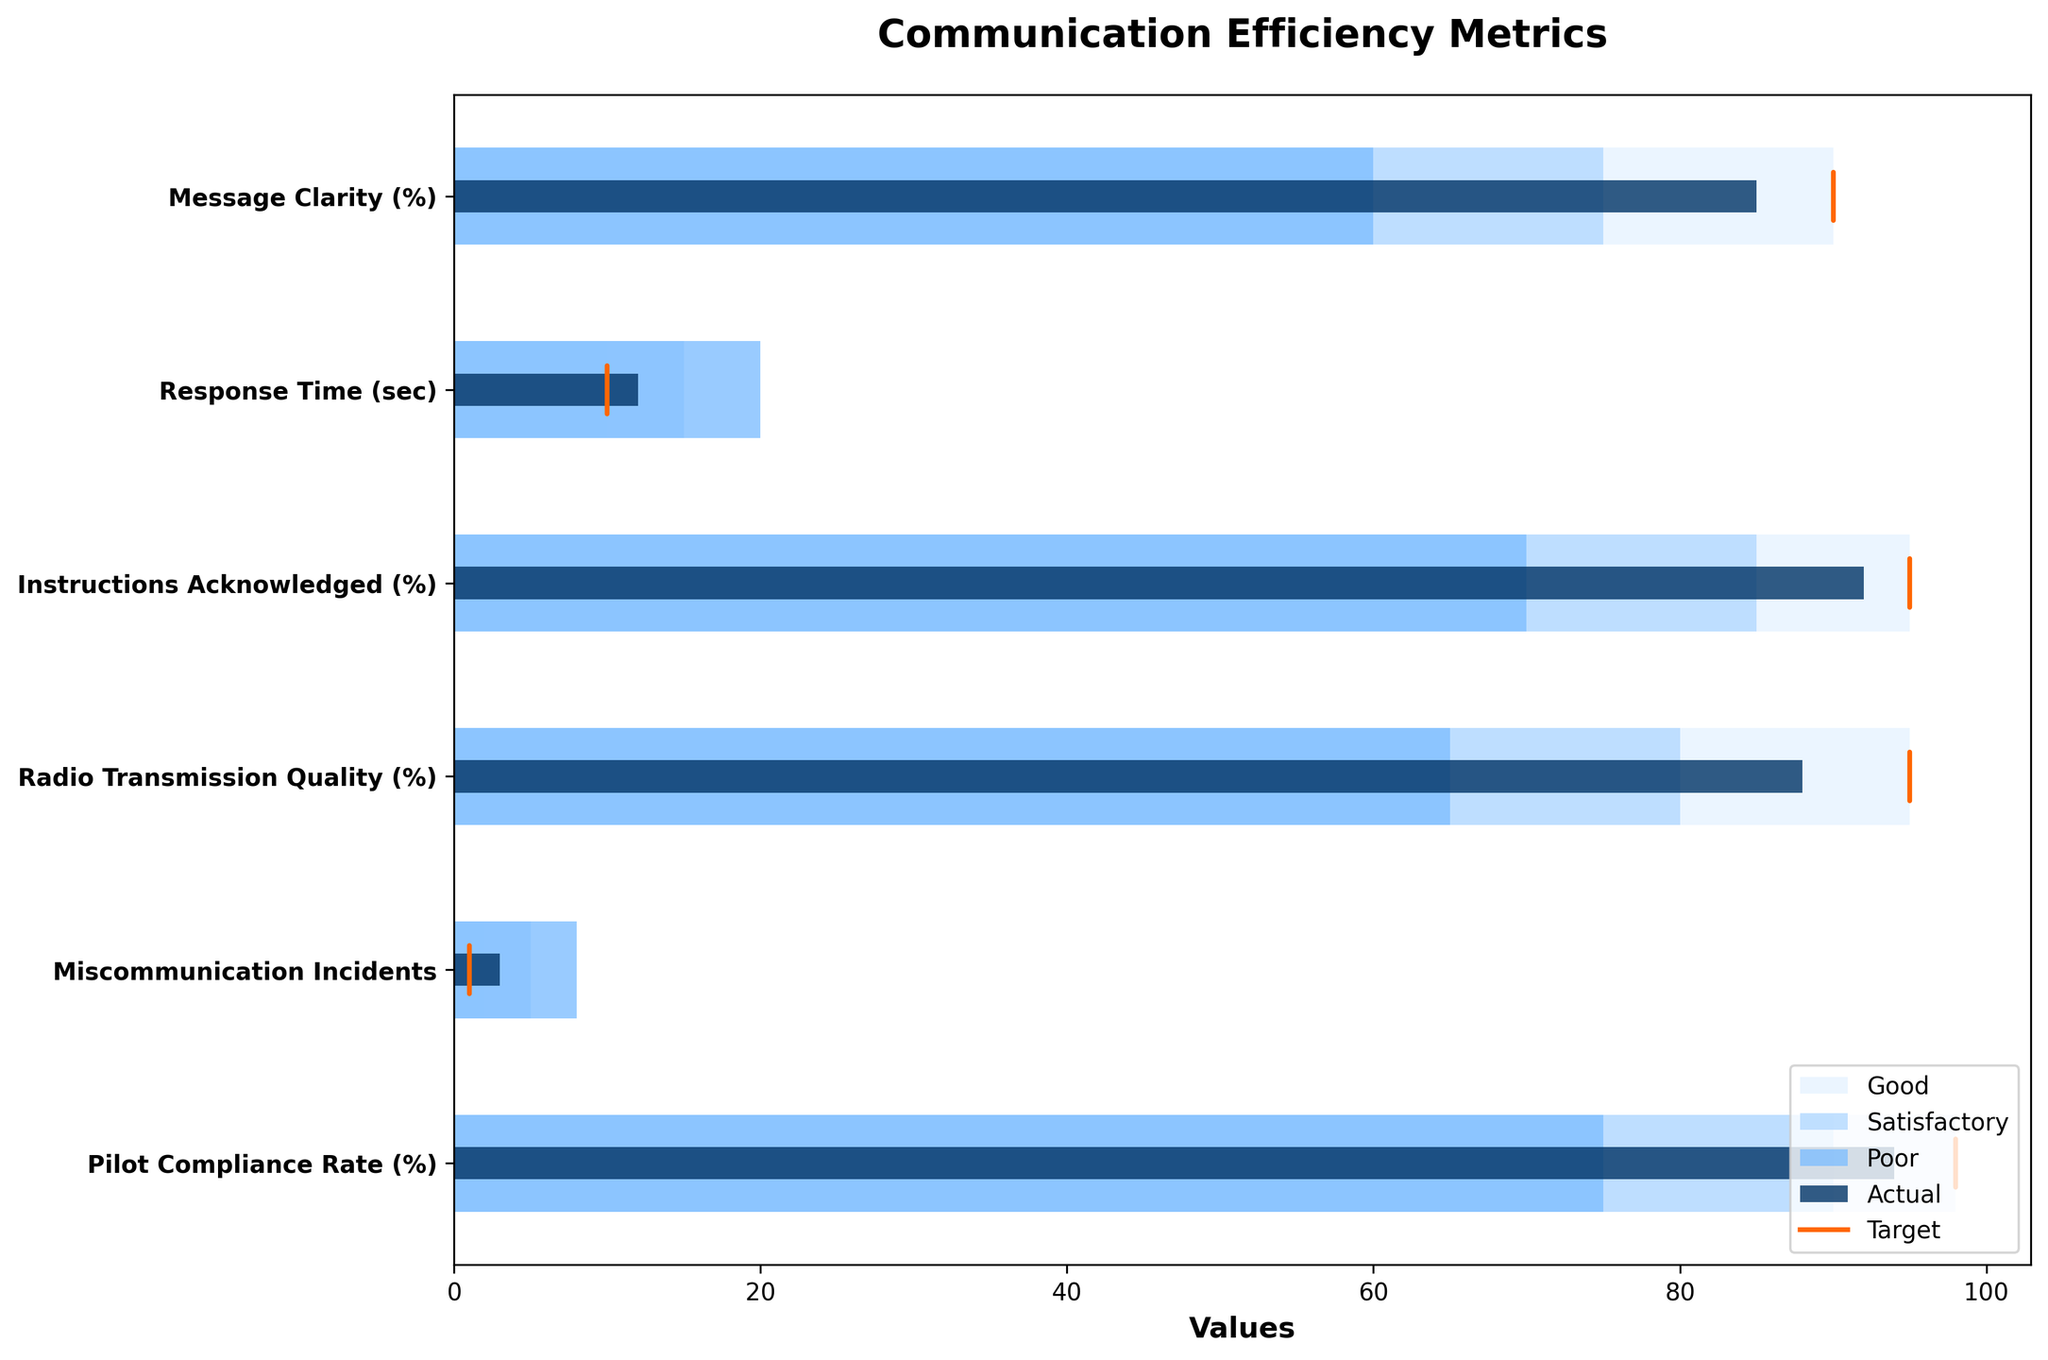What's the title of the plot? The title is usually placed at the top of the figure and summarizes the main focus of the plot.
Answer: Communication Efficiency Metrics Which metric has the lowest actual value? By observing the actual values represented by the dark bars, the metric with the smallest bar is “Miscommunication Incidents”.
Answer: Miscommunication Incidents How many metrics have an actual value that exceeds their target? Compare the end of each dark bar (actual value) with the corresponding orange line (target value). None of the actual values exceed their target values.
Answer: 0 How many metrics fall into the "Good" category based on their actual values? Any actual value bar that reaches or exceeds the boundary of the light blue area (marked as “Good”) is considered as falling into the "Good" category.
Answer: 0 Which metric is furthest from reaching its target value? Find the metric where the difference between the actual value (end of the dark bar) and the target value (orange line) is the greatest. This is “Miscommunication Incidents”.
Answer: Miscommunication Incidents What's the difference between the target and actual value for "Response Time (sec)"? Subtract the actual value for "Response Time (sec)" from its target value: 12 (actual) - 10 (target) = 2.
Answer: 2 Which metric has the closest actual value to its target? Compare the distances between the actual values (end of the dark bars) and the target values (orange lines). The closest is "Message Clarity (%)" with a difference of 5.
Answer: Message Clarity (%) Rank the metrics from worst to best in terms of how close their actual values are to their "Good" thresholds. Calculate the difference between the actual value and the "Good" threshold for each metric, ranking them from greatest to smallest. The order is: "Miscommunication Incidents", "Response Time (sec)", "Radio Transmission Quality (%)", "Pilot Compliance Rate (%)", "Instructions Acknowledged (%)", "Message Clarity (%)".
Answer: Miscommunication Incidents, Response Time, Radio Transmission Quality, Pilot Compliance Rate, Instructions Acknowledged, Message Clarity Which metric has the highest Target value? Look for the highest orange line representing the target value. The metric "Pilot Compliance Rate (%)" has a target value of 98.
Answer: Pilot Compliance Rate (%) Is the actual value of "Radio Transmission Quality (%)" within the "Satisfactory" range? Observe if the dark bar (actual value) for "Radio Transmission Quality (%)" lies within the medium blue area (satisfactory range). It does.
Answer: Yes 